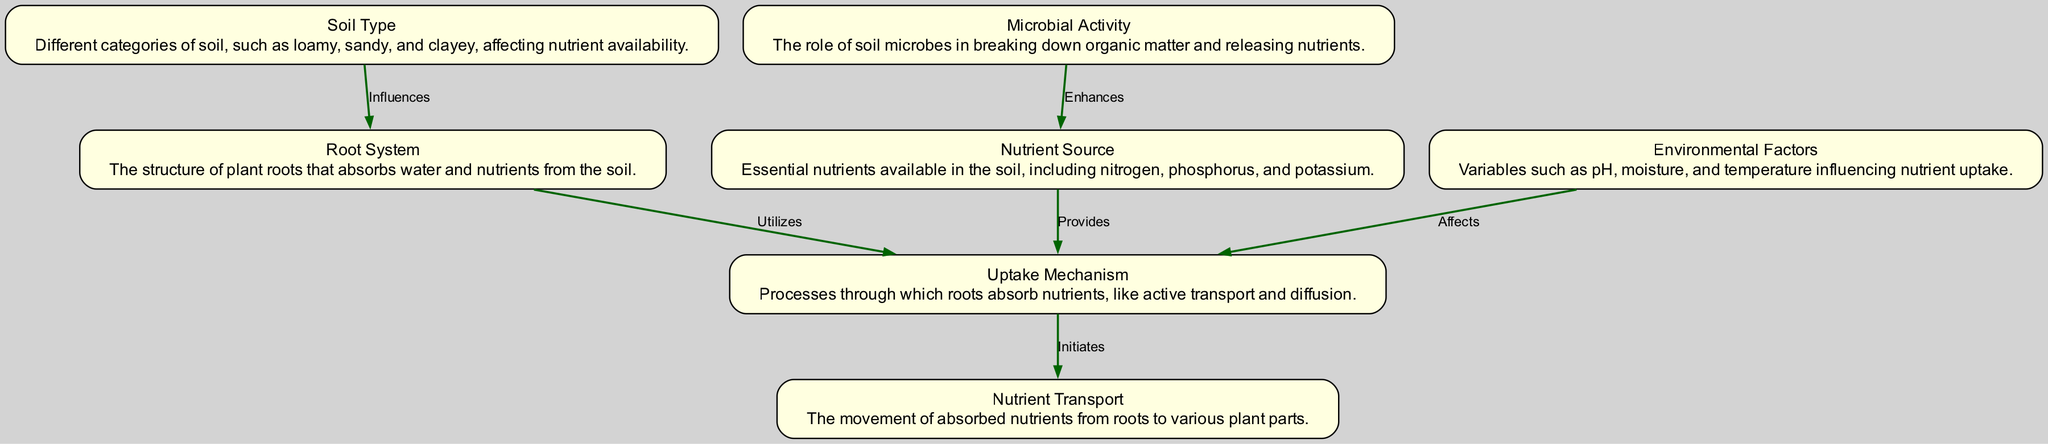What is the first element in the sequence? The first element in the sequence diagram is "Soil Type," as it is the starting point leading to the other elements.
Answer: Soil Type How many nodes are in the diagram? The diagram includes six distinct nodes: Soil Type, Root System, Nutrient Source, Uptake Mechanism, Environmental Factors, and Microbial Activity.
Answer: Six What influences the uptake mechanism according to the diagram? The diagram indicates that both the Root System and Environmental Factors influence the Uptake Mechanism, demonstrating a direct relationship between these nodes.
Answer: Root System, Environmental Factors Which element enhances the Nutrient Source? The diagram shows that Microbial Activity enhances the Nutrient Source, indicating that soil microbes play a significant role in this process.
Answer: Microbial Activity In total, how many edges are present in the diagram? The diagram contains five edges that represent the relationships between the nodes, illustrating the sequence of interactions among them.
Answer: Five What is the final step in the sequence? The final step in the sequence is depicted as "Nutrient Transport," which is the process that occurs following the Uptake Mechanism.
Answer: Nutrient Transport Which two elements interact to provide nutrients during the uptake mechanism? The diagram specifies that the Nutrient Source provides nutrients to the Uptake Mechanism, showing a direct interaction between these two elements.
Answer: Nutrient Source What role do environmental factors play in the uptake mechanism? Environmental Factors affect the Uptake Mechanism, suggesting that various environmental conditions can influence how roots absorb nutrients.
Answer: Affects Which element utilizes the root system? According to the diagram, the Uptake Mechanism utilizes the Root System to absorb essential nutrients from the soil.
Answer: Utilizes 